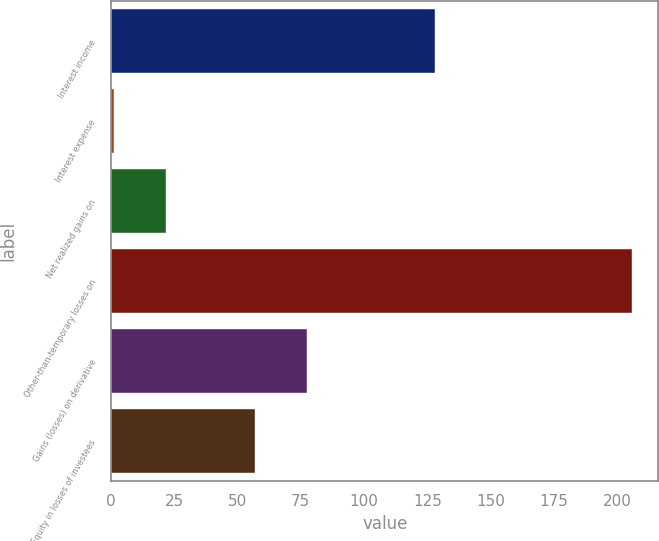Convert chart. <chart><loc_0><loc_0><loc_500><loc_500><bar_chart><fcel>Interest income<fcel>Interest expense<fcel>Net realized gains on<fcel>Other-than-temporary losses on<fcel>Gains (losses) on derivative<fcel>Equity in losses of investees<nl><fcel>128<fcel>1<fcel>21.5<fcel>206<fcel>77.5<fcel>57<nl></chart> 